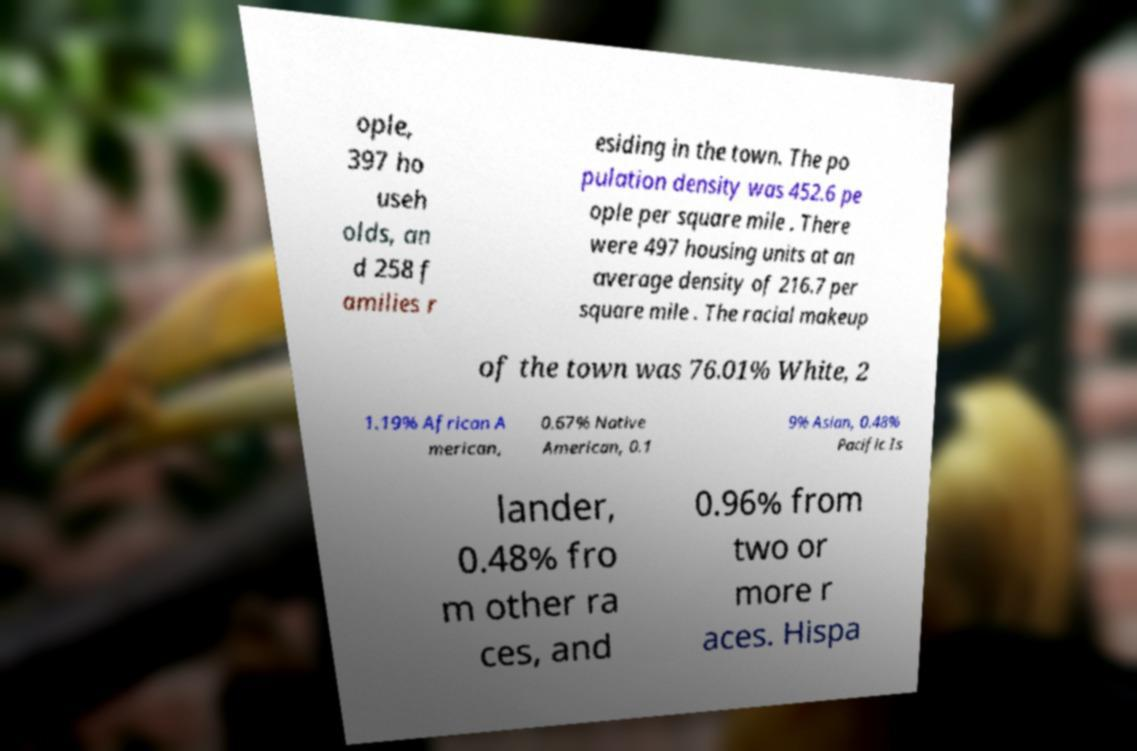Could you assist in decoding the text presented in this image and type it out clearly? ople, 397 ho useh olds, an d 258 f amilies r esiding in the town. The po pulation density was 452.6 pe ople per square mile . There were 497 housing units at an average density of 216.7 per square mile . The racial makeup of the town was 76.01% White, 2 1.19% African A merican, 0.67% Native American, 0.1 9% Asian, 0.48% Pacific Is lander, 0.48% fro m other ra ces, and 0.96% from two or more r aces. Hispa 